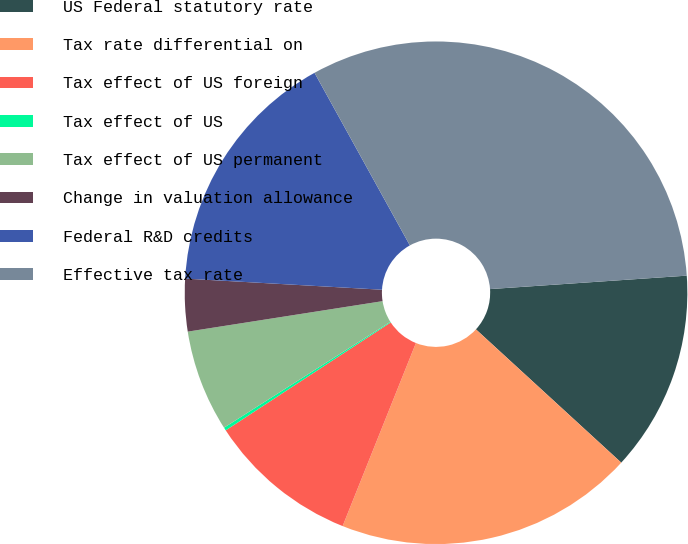<chart> <loc_0><loc_0><loc_500><loc_500><pie_chart><fcel>US Federal statutory rate<fcel>Tax rate differential on<fcel>Tax effect of US foreign<fcel>Tax effect of US<fcel>Tax effect of US permanent<fcel>Change in valuation allowance<fcel>Federal R&D credits<fcel>Effective tax rate<nl><fcel>12.9%<fcel>19.25%<fcel>9.72%<fcel>0.2%<fcel>6.55%<fcel>3.37%<fcel>16.07%<fcel>31.95%<nl></chart> 